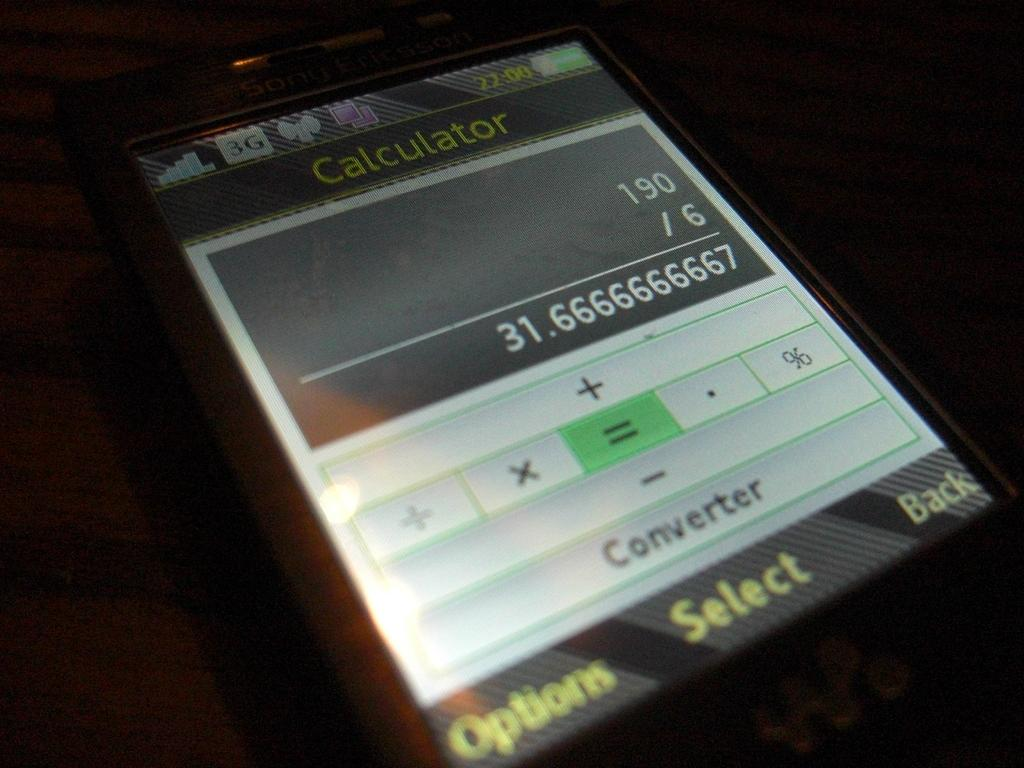<image>
Write a terse but informative summary of the picture. A phone that has the calculator app pulled up doing division. 